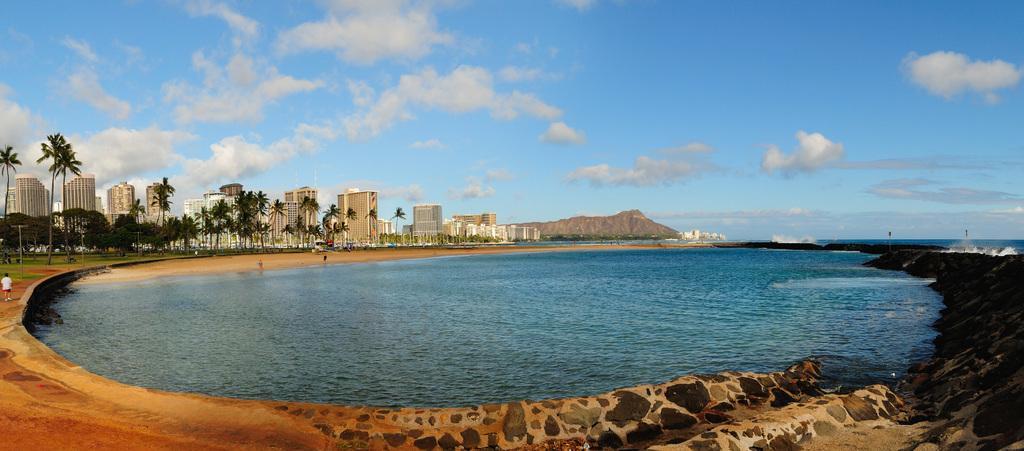In one or two sentences, can you explain what this image depicts? This image consists of an ocean. In the middle, there is a water. At the bottom, there is ground. To the left, there are many building along with the trees. At the top, there are clouds in the sky. 